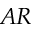Convert formula to latex. <formula><loc_0><loc_0><loc_500><loc_500>A R</formula> 